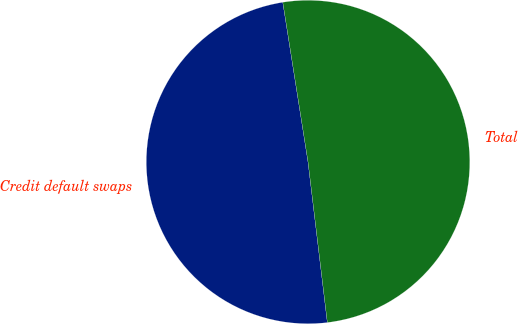<chart> <loc_0><loc_0><loc_500><loc_500><pie_chart><fcel>Credit default swaps<fcel>Total<nl><fcel>49.41%<fcel>50.59%<nl></chart> 